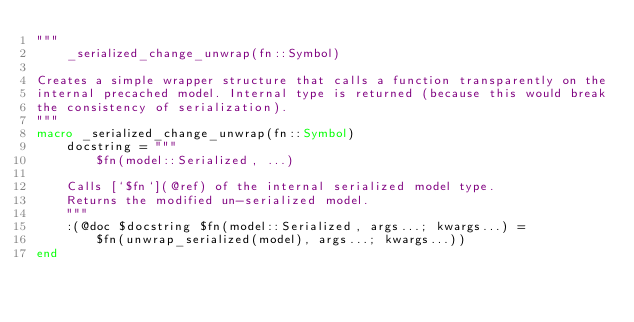<code> <loc_0><loc_0><loc_500><loc_500><_Julia_>"""
    _serialized_change_unwrap(fn::Symbol)

Creates a simple wrapper structure that calls a function transparently on the
internal precached model. Internal type is returned (because this would break
the consistency of serialization).
"""
macro _serialized_change_unwrap(fn::Symbol)
    docstring = """
        $fn(model::Serialized, ...)

    Calls [`$fn`](@ref) of the internal serialized model type.
    Returns the modified un-serialized model.
    """
    :(@doc $docstring $fn(model::Serialized, args...; kwargs...) =
        $fn(unwrap_serialized(model), args...; kwargs...))
end
</code> 